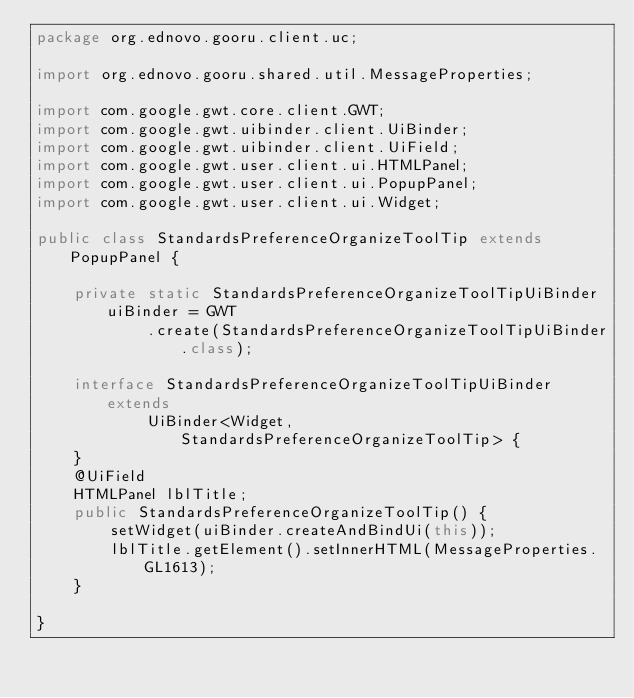Convert code to text. <code><loc_0><loc_0><loc_500><loc_500><_Java_>package org.ednovo.gooru.client.uc;

import org.ednovo.gooru.shared.util.MessageProperties;

import com.google.gwt.core.client.GWT;
import com.google.gwt.uibinder.client.UiBinder;
import com.google.gwt.uibinder.client.UiField;
import com.google.gwt.user.client.ui.HTMLPanel;
import com.google.gwt.user.client.ui.PopupPanel;
import com.google.gwt.user.client.ui.Widget;

public class StandardsPreferenceOrganizeToolTip extends PopupPanel {

	private static StandardsPreferenceOrganizeToolTipUiBinder uiBinder = GWT
			.create(StandardsPreferenceOrganizeToolTipUiBinder.class);

	interface StandardsPreferenceOrganizeToolTipUiBinder extends
			UiBinder<Widget, StandardsPreferenceOrganizeToolTip> {
	}
	@UiField
	HTMLPanel lblTitle;
	public StandardsPreferenceOrganizeToolTip() {
		setWidget(uiBinder.createAndBindUi(this));
		lblTitle.getElement().setInnerHTML(MessageProperties.GL1613);
	}

}
</code> 